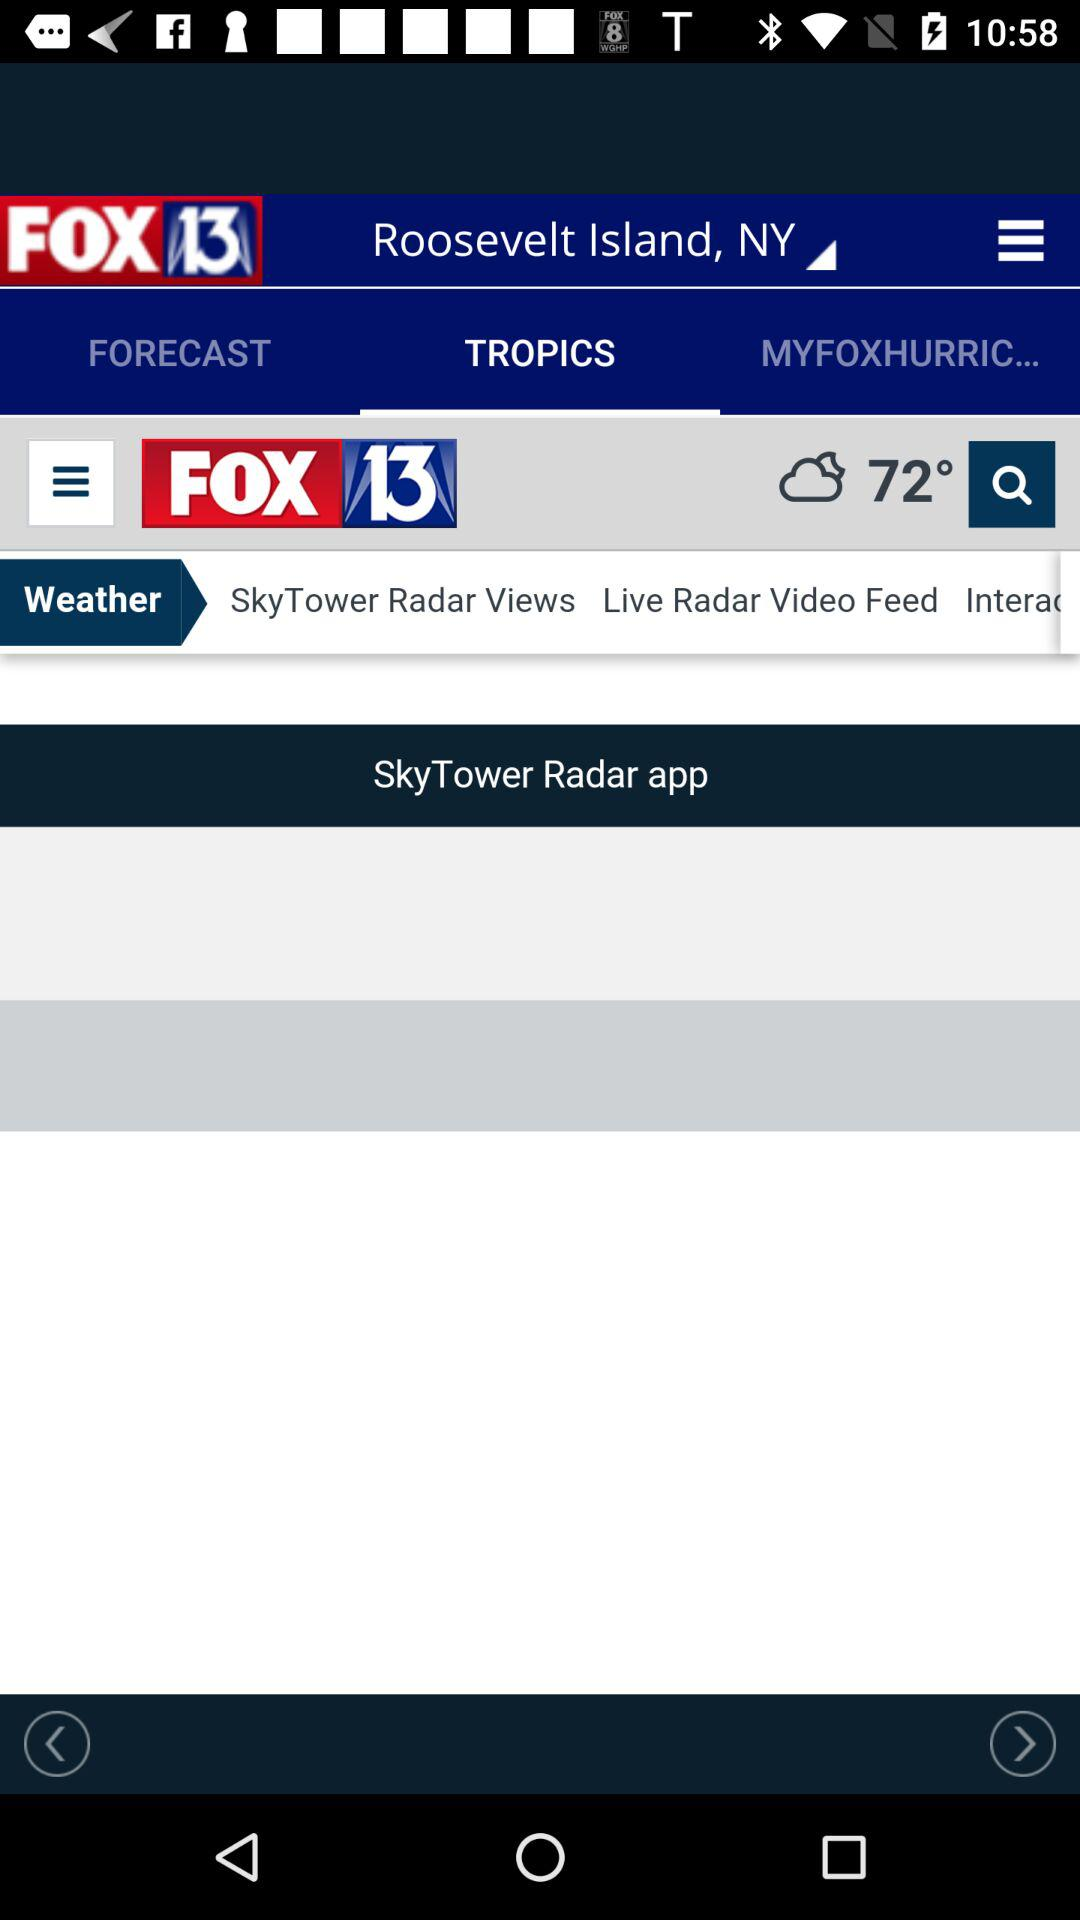What is the temperature? The temperature is 72 degrees. 